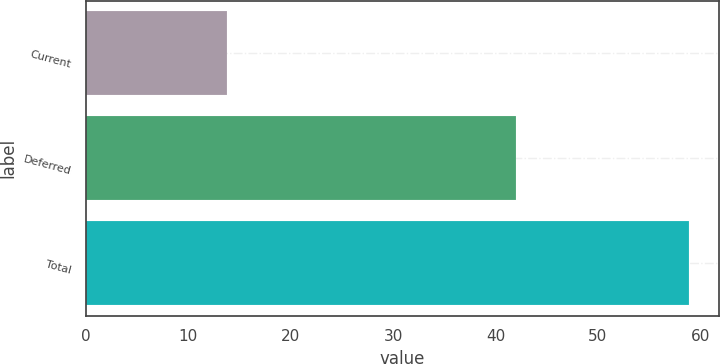Convert chart to OTSL. <chart><loc_0><loc_0><loc_500><loc_500><bar_chart><fcel>Current<fcel>Deferred<fcel>Total<nl><fcel>13.8<fcel>42<fcel>58.9<nl></chart> 